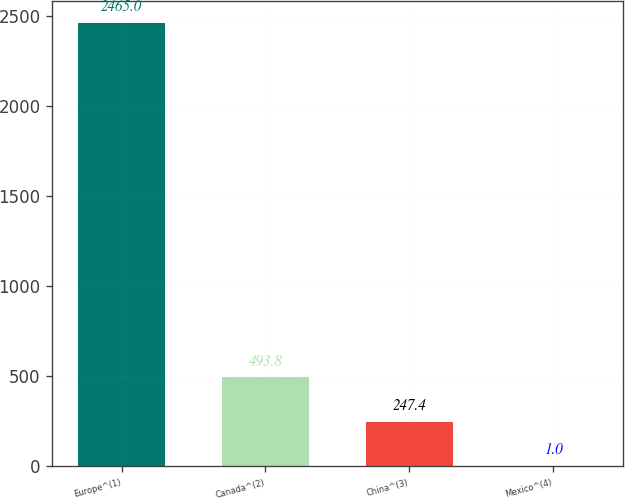Convert chart. <chart><loc_0><loc_0><loc_500><loc_500><bar_chart><fcel>Europe^(1)<fcel>Canada^(2)<fcel>China^(3)<fcel>Mexico^(4)<nl><fcel>2465<fcel>493.8<fcel>247.4<fcel>1<nl></chart> 